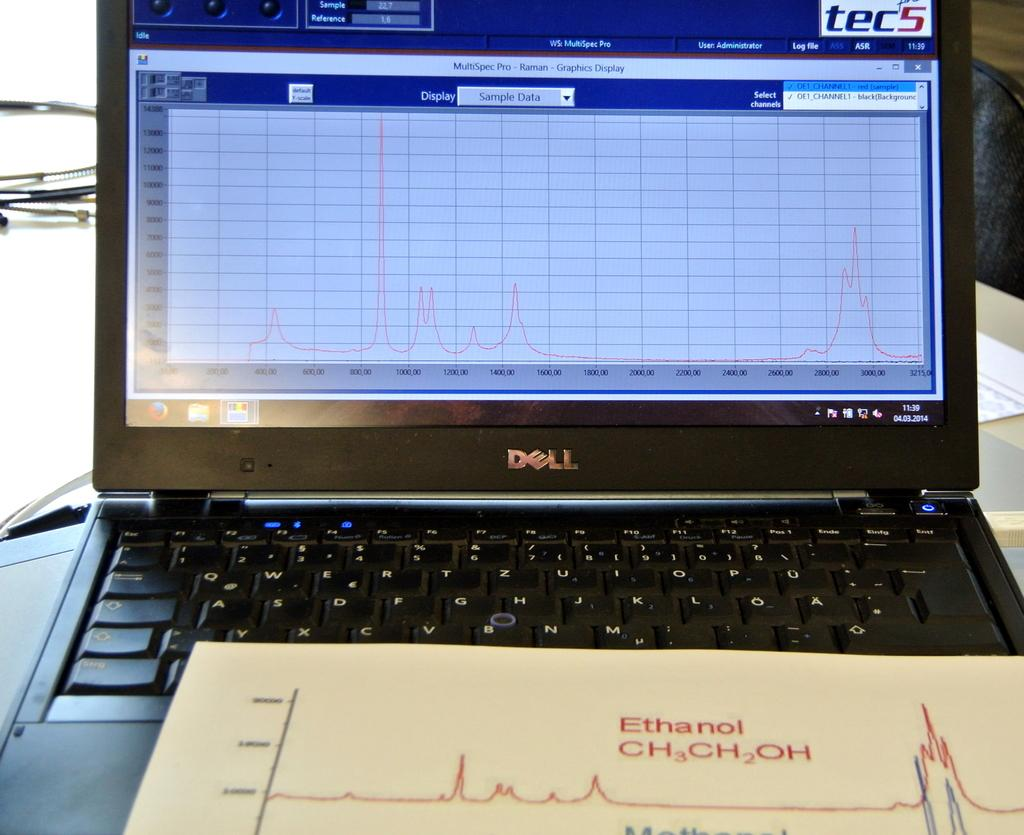<image>
Offer a succinct explanation of the picture presented. Black Dell laptop under a paper that says Ethanol. 